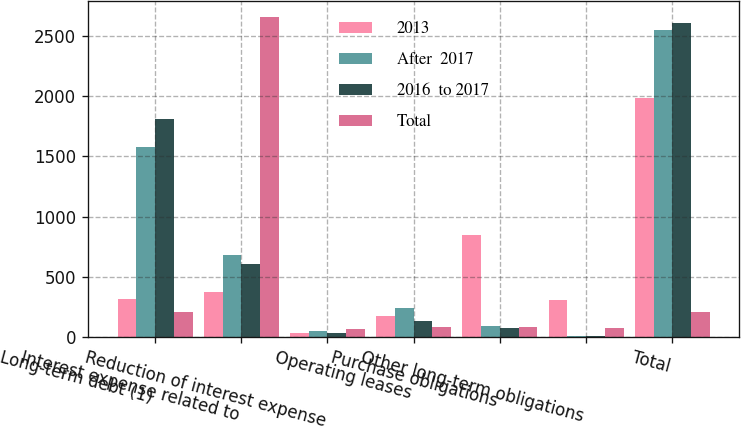Convert chart to OTSL. <chart><loc_0><loc_0><loc_500><loc_500><stacked_bar_chart><ecel><fcel>Long-term debt (1)<fcel>Interest expense related to<fcel>Reduction of interest expense<fcel>Operating leases<fcel>Purchase obligations<fcel>Other long-term obligations<fcel>Total<nl><fcel>2013<fcel>314<fcel>371<fcel>34<fcel>174<fcel>849<fcel>309<fcel>1983<nl><fcel>After  2017<fcel>1576<fcel>683<fcel>54<fcel>238<fcel>95<fcel>12<fcel>2550<nl><fcel>2016  to 2017<fcel>1812<fcel>607<fcel>35<fcel>132<fcel>78<fcel>13<fcel>2607<nl><fcel>Total<fcel>206<fcel>2653<fcel>69<fcel>85<fcel>86<fcel>74<fcel>206<nl></chart> 